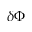<formula> <loc_0><loc_0><loc_500><loc_500>\delta \Phi</formula> 